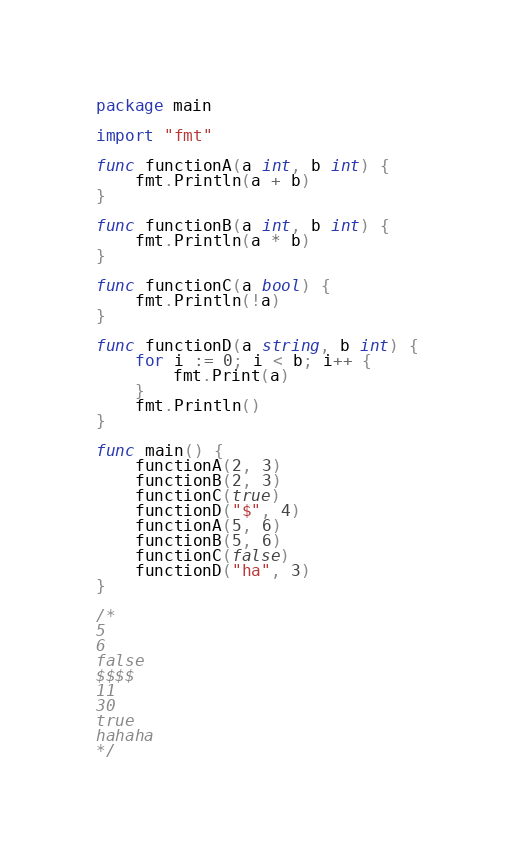<code> <loc_0><loc_0><loc_500><loc_500><_Go_>package main

import "fmt"

func functionA(a int, b int) {
	fmt.Println(a + b)
}

func functionB(a int, b int) {
	fmt.Println(a * b)
}

func functionC(a bool) {
	fmt.Println(!a)
}

func functionD(a string, b int) {
	for i := 0; i < b; i++ {
		fmt.Print(a)
	}
	fmt.Println()
}

func main() {
	functionA(2, 3)
	functionB(2, 3)
	functionC(true)
	functionD("$", 4)
	functionA(5, 6)
	functionB(5, 6)
	functionC(false)
	functionD("ha", 3)
}

/*
5
6
false
$$$$
11
30
true
hahaha
*/
</code> 